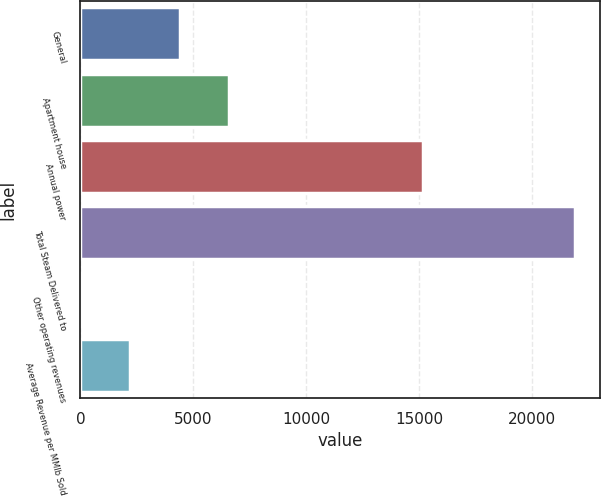Convert chart. <chart><loc_0><loc_0><loc_500><loc_500><bar_chart><fcel>General<fcel>Apartment house<fcel>Annual power<fcel>Total Steam Delivered to<fcel>Other operating revenues<fcel>Average Revenue per MMlb Sold<nl><fcel>4405.4<fcel>6595.1<fcel>15195<fcel>21923<fcel>26<fcel>2215.7<nl></chart> 